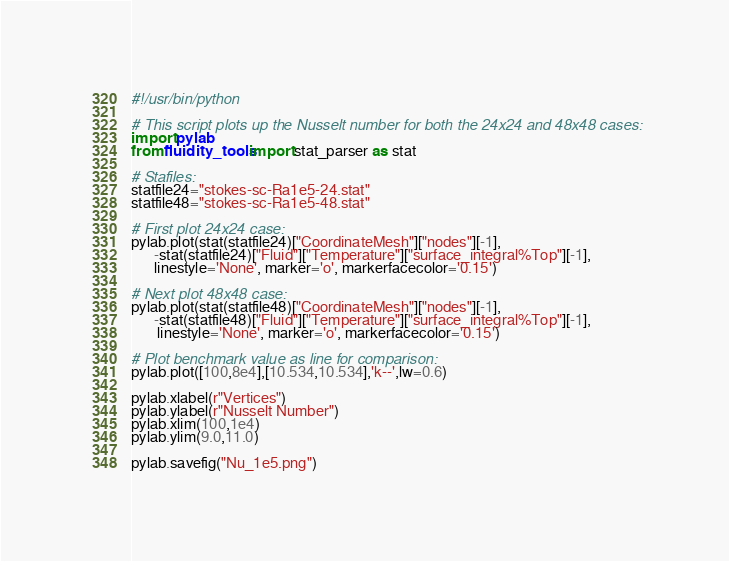Convert code to text. <code><loc_0><loc_0><loc_500><loc_500><_Python_>#!/usr/bin/python

# This script plots up the Nusselt number for both the 24x24 and 48x48 cases:
import pylab
from fluidity_tools import stat_parser as stat

# Stafiles:
statfile24="stokes-sc-Ra1e5-24.stat"
statfile48="stokes-sc-Ra1e5-48.stat"

# First plot 24x24 case:
pylab.plot(stat(statfile24)["CoordinateMesh"]["nodes"][-1],
      -stat(statfile24)["Fluid"]["Temperature"]["surface_integral%Top"][-1],
      linestyle='None', marker='o', markerfacecolor='0.15')

# Next plot 48x48 case:
pylab.plot(stat(statfile48)["CoordinateMesh"]["nodes"][-1],
      -stat(statfile48)["Fluid"]["Temperature"]["surface_integral%Top"][-1],
       linestyle='None', marker='o', markerfacecolor='0.15')

# Plot benchmark value as line for comparison:
pylab.plot([100,8e4],[10.534,10.534],'k--',lw=0.6)

pylab.xlabel(r"Vertices")
pylab.ylabel(r"Nusselt Number")
pylab.xlim(100,1e4)
pylab.ylim(9.0,11.0)

pylab.savefig("Nu_1e5.png")
</code> 